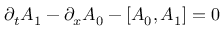Convert formula to latex. <formula><loc_0><loc_0><loc_500><loc_500>\partial _ { t } A _ { 1 } - \partial _ { x } A _ { 0 } - \left [ A _ { 0 } , A _ { 1 } \right ] = 0</formula> 